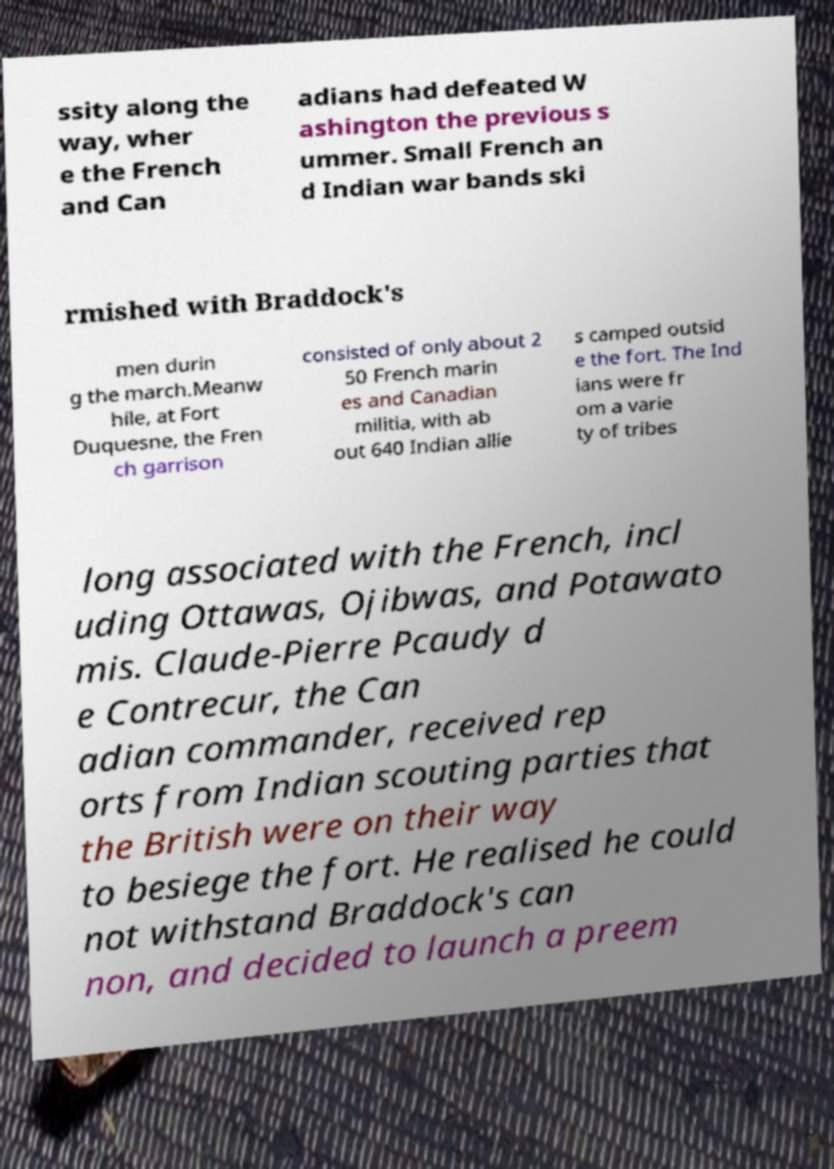For documentation purposes, I need the text within this image transcribed. Could you provide that? ssity along the way, wher e the French and Can adians had defeated W ashington the previous s ummer. Small French an d Indian war bands ski rmished with Braddock's men durin g the march.Meanw hile, at Fort Duquesne, the Fren ch garrison consisted of only about 2 50 French marin es and Canadian militia, with ab out 640 Indian allie s camped outsid e the fort. The Ind ians were fr om a varie ty of tribes long associated with the French, incl uding Ottawas, Ojibwas, and Potawato mis. Claude-Pierre Pcaudy d e Contrecur, the Can adian commander, received rep orts from Indian scouting parties that the British were on their way to besiege the fort. He realised he could not withstand Braddock's can non, and decided to launch a preem 